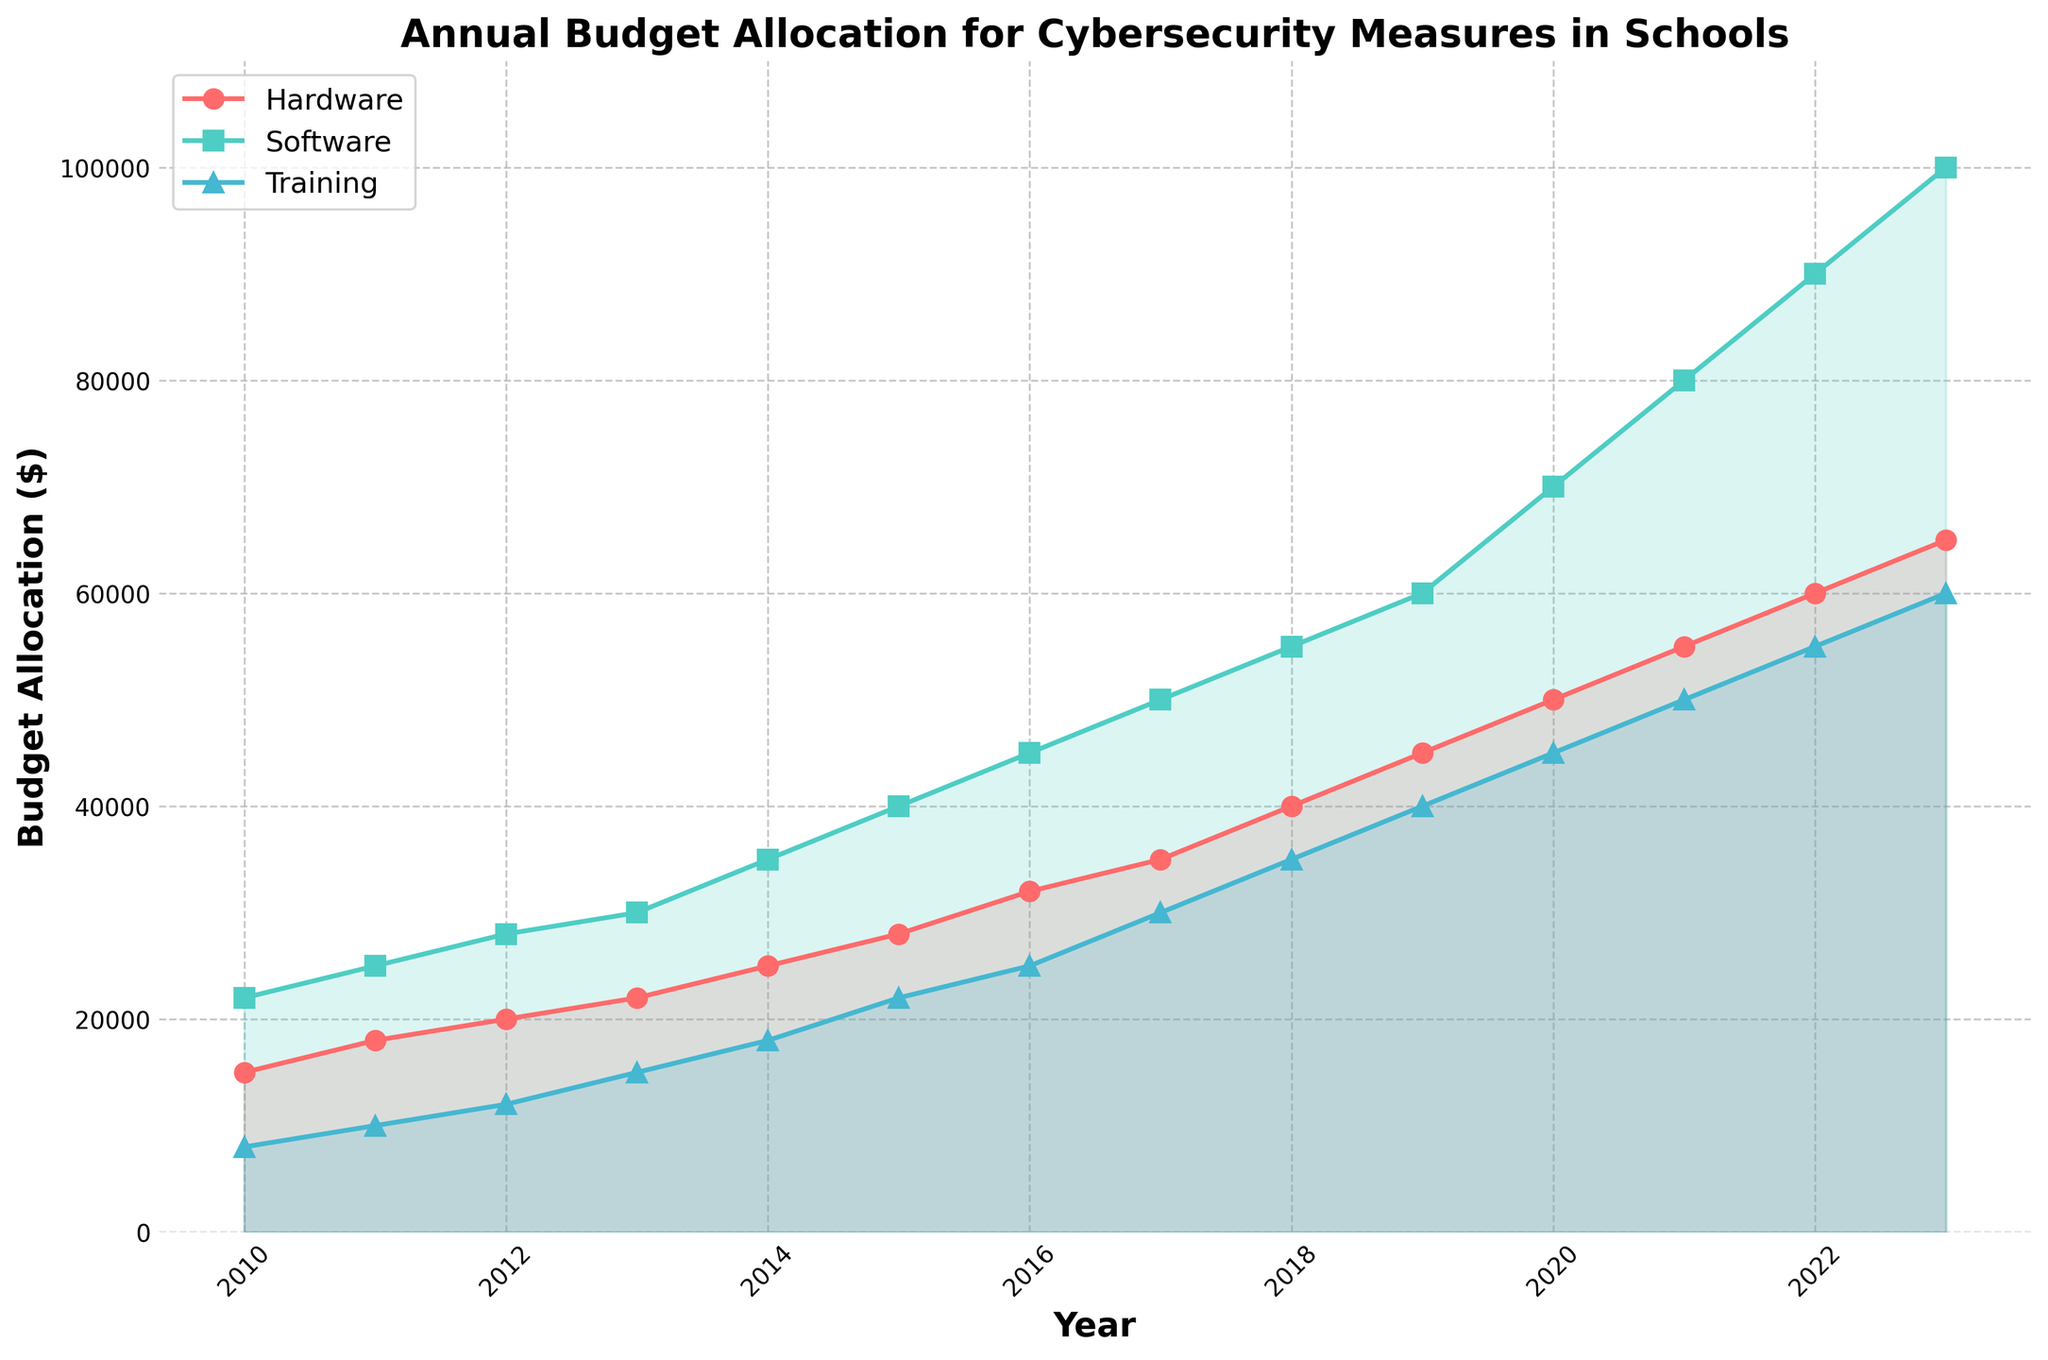What was the budget allocation for hardware and training combined in 2013? In 2013, the hardware budget was $22,000 and the training budget was $15,000. Summing these values gives: $22,000 + $15,000 = $37,000
Answer: $37,000 In what year was the software budget first double the hardware budget? To find the first year when the software budget was double the hardware budget, compare each year's allocation. In 2014, the hardware budget was $25,000 and the software budget was $35,000, which is not yet double. However, in 2015, the hardware budget was $28,000 and the software budget was $40,000, satisfying the condition.
Answer: 2015 Which part of the budget saw the highest increase between consecutive years? To determine the highest increase, subtract the previous year's budget from the current year's budget for hardware, software, and training. The highest increase occurred for the software budget from 2021 ($80,000) to 2022 ($90,000), an increase of $10,000.
Answer: Software from 2021 to 2022 What is the total budget allocation for all categories in 2023? Summing the hardware, software, and training budgets for 2023 gives: $65,000 (hardware) + $100,000 (software) + $60,000 (training) = $225,000
Answer: $225,000 By how much did the training budget change from 2020 to 2021? The training budget in 2020 was $45,000 and in 2021 it was $50,000. The difference is: $50,000 - $45,000 = $5,000
Answer: $5,000 Which category has the smallest budget increase between 2016 and 2017? The increase for hardware from 2016 ($32,000) to 2017 ($35,000) is $3,000, for software from 2016 ($45,000) to 2017 ($50,000) is $5,000, and for training from 2016 ($25,000) to 2017 ($30,000) is $5,000. The smallest increase is in hardware.
Answer: Hardware In what year did the training budget surpass $20,000? Looking at the data, the training budget surpasses $20,000 in 2015, when it was $22,000.
Answer: 2015 What is the average annual software budget over the entire period? Sum the software budgets from 2010 to 2023 and divide by the number of years. The sum is: $22,000 + $25,000 + $28,000 + $30,000 + $35,000 + $40,000 + $45,000 + $50,000 + $55,000 + $60,000 + $70,000 + $80,000 + $90,000 + $100,000 = $730,000. The average is $730,000 / 14 = $52,143 approx.
Answer: $52,143 How does the hardware budget trend over the years compare to the software budget trend? Looking at the trends, both hardware and software budgets show an increasing pattern over the years. However, the software budget increases at a higher rate than the hardware budget. For instance, starting from $22,000 in 2010, the software budget reaches $100,000 in 2023, while the hardware budget increases from $15,000 to $65,000 over the same period.
Answer: Software budget increases at a higher rate Which year saw the most substantial single-year budget allocation change for hardware? Calculate the change for each year: the most substantial change occurred from 2015 ($28,000) to 2016 ($32,000), an increase of $4,000.
Answer: 2016 